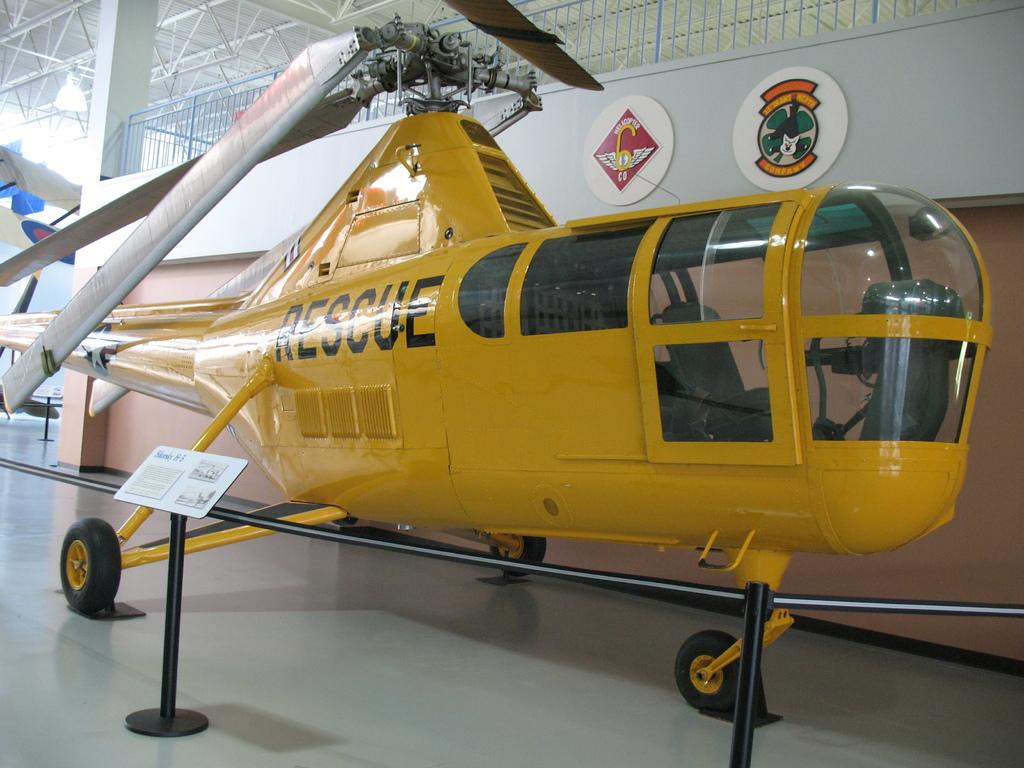<image>
Summarize the visual content of the image. A yellow rescue helicopter stands in a museum. 